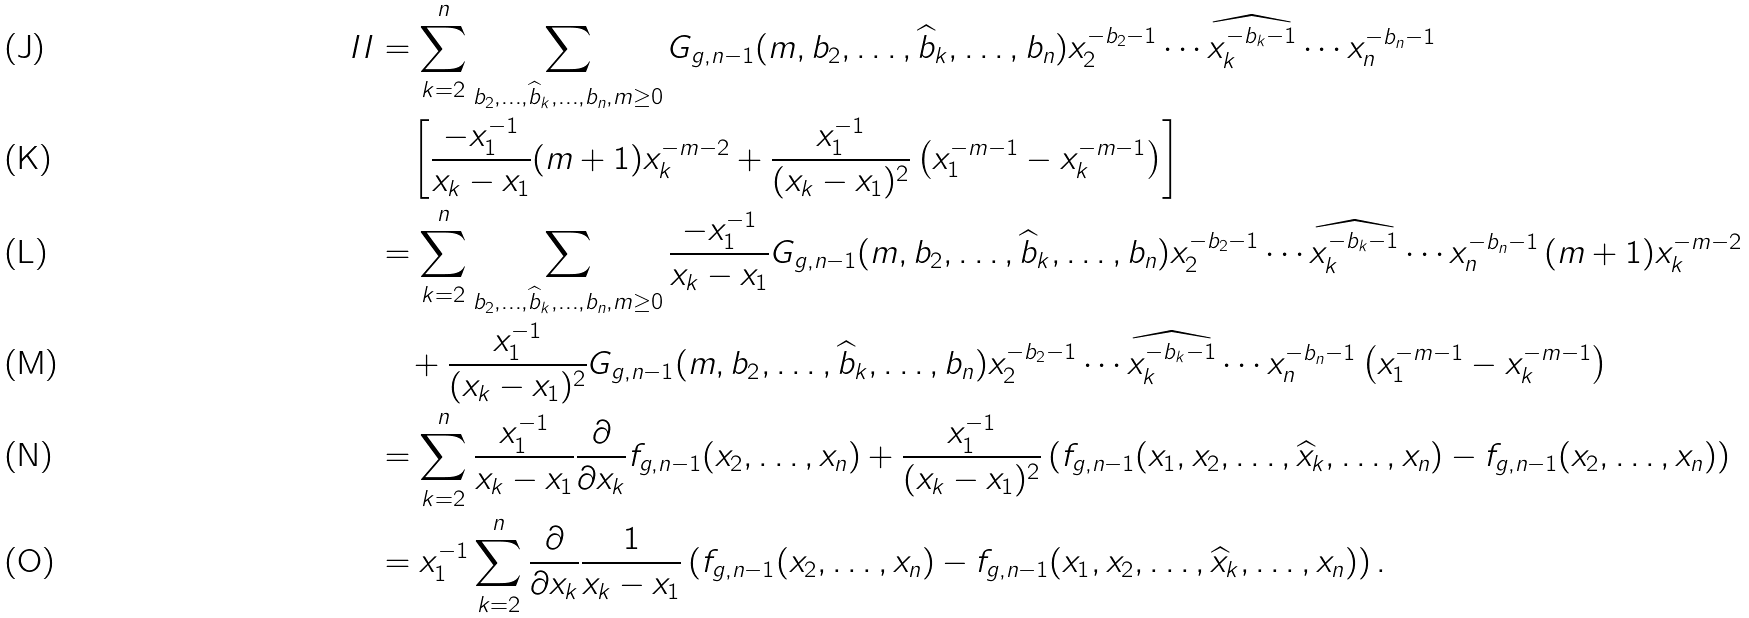<formula> <loc_0><loc_0><loc_500><loc_500>I I & = \sum _ { k = 2 } ^ { n } \sum _ { b _ { 2 } , \dots , \widehat { b } _ { k } , \dots , b _ { n } , m \geq 0 } G _ { g , n - 1 } ( m , b _ { 2 } , \dots , \widehat { b } _ { k } , \dots , b _ { n } ) x _ { 2 } ^ { - b _ { 2 } - 1 } \cdots \widehat { x _ { k } ^ { - b _ { k } - 1 } } \cdots x _ { n } ^ { - b _ { n } - 1 } \\ & \quad \left [ \frac { - x _ { 1 } ^ { - 1 } } { x _ { k } - x _ { 1 } } ( m + 1 ) x _ { k } ^ { - m - 2 } + \frac { x _ { 1 } ^ { - 1 } } { ( x _ { k } - x _ { 1 } ) ^ { 2 } } \left ( x _ { 1 } ^ { - m - 1 } - x _ { k } ^ { - m - 1 } \right ) \right ] \\ & = \sum _ { k = 2 } ^ { n } \sum _ { b _ { 2 } , \dots , \widehat { b } _ { k } , \dots , b _ { n } , m \geq 0 } \frac { - x _ { 1 } ^ { - 1 } } { x _ { k } - x _ { 1 } } G _ { g , n - 1 } ( m , b _ { 2 } , \dots , \widehat { b } _ { k } , \dots , b _ { n } ) x _ { 2 } ^ { - b _ { 2 } - 1 } \cdots \widehat { x _ { k } ^ { - b _ { k } - 1 } } \cdots x _ { n } ^ { - b _ { n } - 1 } \, ( m + 1 ) x _ { k } ^ { - m - 2 } \\ & \quad + \frac { x _ { 1 } ^ { - 1 } } { ( x _ { k } - x _ { 1 } ) ^ { 2 } } G _ { g , n - 1 } ( m , b _ { 2 } , \dots , \widehat { b } _ { k } , \dots , b _ { n } ) x _ { 2 } ^ { - b _ { 2 } - 1 } \cdots \widehat { x _ { k } ^ { - b _ { k } - 1 } } \cdots x _ { n } ^ { - b _ { n } - 1 } \left ( x _ { 1 } ^ { - m - 1 } - x _ { k } ^ { - m - 1 } \right ) \\ & = \sum _ { k = 2 } ^ { n } \frac { x _ { 1 } ^ { - 1 } } { x _ { k } - x _ { 1 } } \frac { \partial } { \partial x _ { k } } f _ { g , n - 1 } ( x _ { 2 } , \dots , x _ { n } ) + \frac { x _ { 1 } ^ { - 1 } } { ( x _ { k } - x _ { 1 } ) ^ { 2 } } \left ( f _ { g , n - 1 } ( x _ { 1 } , x _ { 2 } , \dots , \widehat { x } _ { k } , \dots , x _ { n } ) - f _ { g , n - 1 } ( x _ { 2 } , \dots , x _ { n } ) \right ) \\ & = x _ { 1 } ^ { - 1 } \sum _ { k = 2 } ^ { n } \frac { \partial } { \partial x _ { k } } \frac { 1 } { x _ { k } - x _ { 1 } } \left ( f _ { g , n - 1 } ( x _ { 2 } , \dots , x _ { n } ) - f _ { g , n - 1 } ( x _ { 1 } , x _ { 2 } , \dots , \widehat { x } _ { k } , \dots , x _ { n } ) \right ) .</formula> 